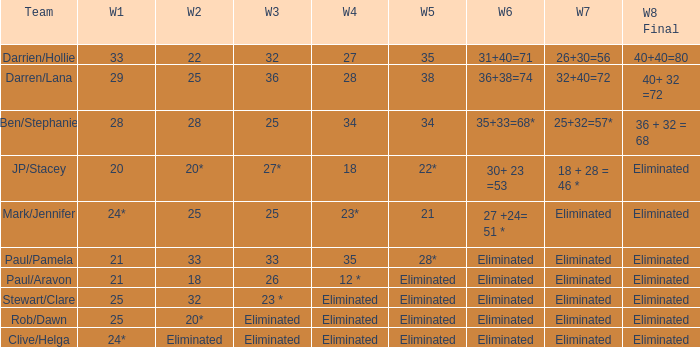Name the week 6 when week 3 is 25 and week 7 is eliminated 27 +24= 51 *. 